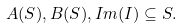<formula> <loc_0><loc_0><loc_500><loc_500>A ( S ) , B ( S ) , I m ( I ) \subseteq S .</formula> 